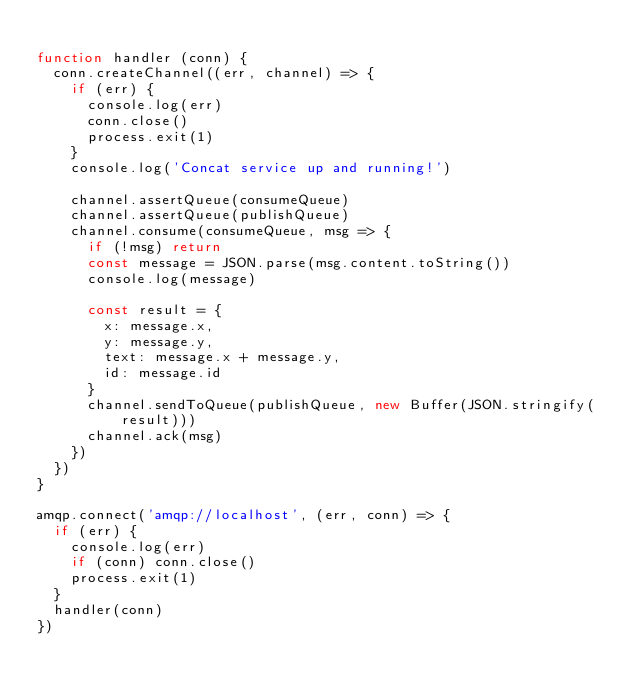Convert code to text. <code><loc_0><loc_0><loc_500><loc_500><_JavaScript_>
function handler (conn) {
  conn.createChannel((err, channel) => {
    if (err) {
      console.log(err)
      conn.close()
      process.exit(1)
    }
    console.log('Concat service up and running!')

    channel.assertQueue(consumeQueue)
    channel.assertQueue(publishQueue)
    channel.consume(consumeQueue, msg => {
      if (!msg) return
      const message = JSON.parse(msg.content.toString())
      console.log(message)

      const result = {
        x: message.x,
        y: message.y,
        text: message.x + message.y,
        id: message.id
      }
      channel.sendToQueue(publishQueue, new Buffer(JSON.stringify(result)))
      channel.ack(msg)
    })
  })
}

amqp.connect('amqp://localhost', (err, conn) => {
  if (err) {
    console.log(err)
    if (conn) conn.close()
    process.exit(1)
  }
  handler(conn)
})
</code> 